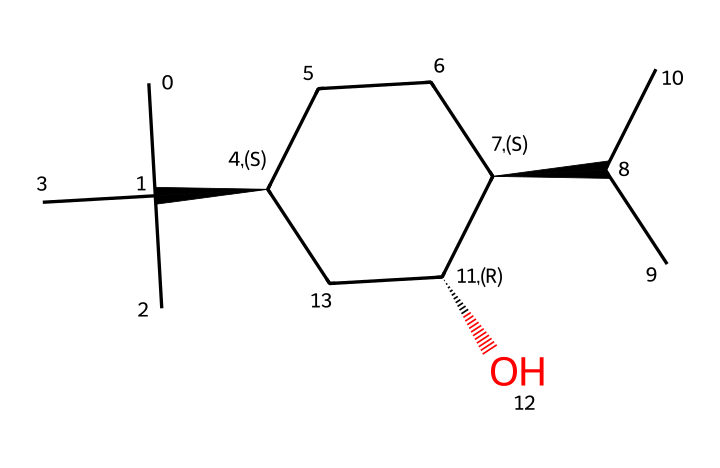What is the name of this chemical? By recognizing the structure and its common representation in organic chemistry, we can identify the molecule as menthol, which is widely known for its mentholated flavor and aroma profile.
Answer: menthol How many carbon atoms are in this molecule? By analyzing the structure represented in the SMILES, we count the carbon atoms indicated in the chains and rings. There are 10 carbon atoms.
Answer: 10 What is the functional group present in this compound? The structure shows a hydroxyl (OH) group attached to the carbon backbone, which indicates the presence of an alcohol functional group.
Answer: alcohol How many chiral centers does this molecule have? By examining the structure, we can identify the carbon atoms that are bonded to four different groups. There are three chiral centers present in menthol.
Answer: 3 What type of compound is menthol classified as? Based on its structure and functional groups, menthol is classified as a monoterpene alcohol, which is commonly found in essential oils.
Answer: monoterpene alcohol What sensory property is menthol primarily known for? Menthol is primarily recognized for its cooling sensation, which it produces when applied to sensitive tissues, making it popular in aromatherapy and cosmetic products.
Answer: cooling sensation In which industries is menthol commonly used? Menthol finds application in various industries including cosmetics, food flavoring, and pharmaceuticals, particularly for its aromatic and soothing properties.
Answer: cosmetics, food, pharmaceuticals 